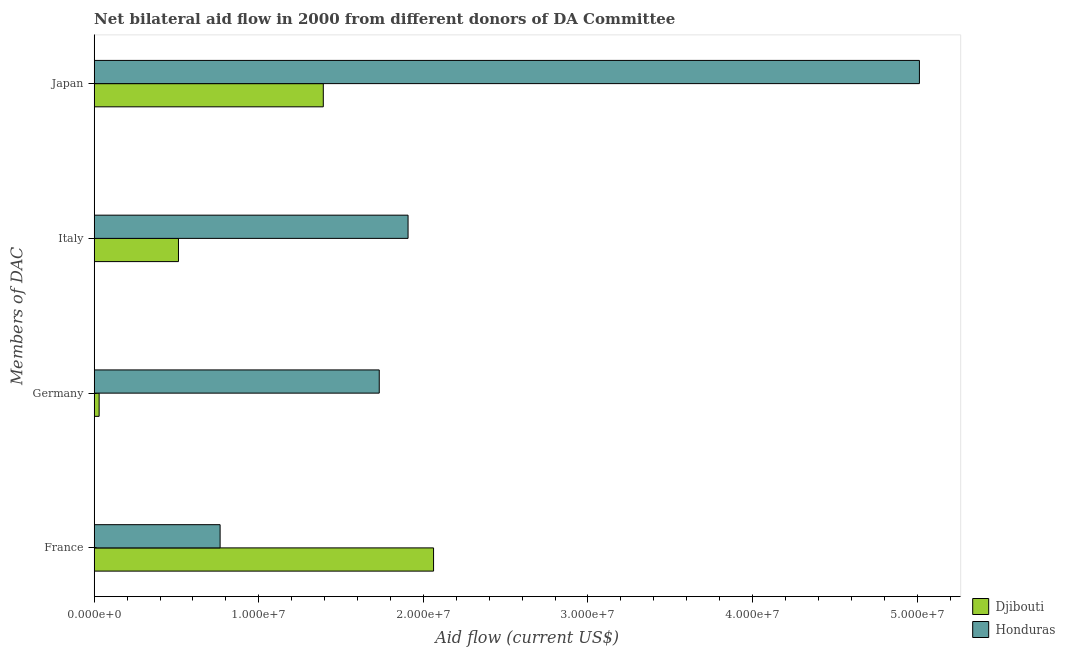How many different coloured bars are there?
Ensure brevity in your answer.  2. Are the number of bars on each tick of the Y-axis equal?
Provide a succinct answer. Yes. How many bars are there on the 2nd tick from the top?
Provide a short and direct response. 2. How many bars are there on the 3rd tick from the bottom?
Keep it short and to the point. 2. What is the label of the 3rd group of bars from the top?
Your answer should be very brief. Germany. What is the amount of aid given by france in Honduras?
Ensure brevity in your answer.  7.65e+06. Across all countries, what is the maximum amount of aid given by italy?
Make the answer very short. 1.91e+07. Across all countries, what is the minimum amount of aid given by france?
Provide a succinct answer. 7.65e+06. In which country was the amount of aid given by france maximum?
Make the answer very short. Djibouti. In which country was the amount of aid given by japan minimum?
Your response must be concise. Djibouti. What is the total amount of aid given by france in the graph?
Provide a succinct answer. 2.83e+07. What is the difference between the amount of aid given by italy in Djibouti and that in Honduras?
Provide a succinct answer. -1.40e+07. What is the difference between the amount of aid given by germany in Honduras and the amount of aid given by italy in Djibouti?
Your answer should be very brief. 1.22e+07. What is the average amount of aid given by germany per country?
Give a very brief answer. 8.81e+06. What is the difference between the amount of aid given by italy and amount of aid given by france in Djibouti?
Provide a succinct answer. -1.55e+07. What is the ratio of the amount of aid given by france in Honduras to that in Djibouti?
Offer a very short reply. 0.37. Is the difference between the amount of aid given by france in Honduras and Djibouti greater than the difference between the amount of aid given by germany in Honduras and Djibouti?
Give a very brief answer. No. What is the difference between the highest and the second highest amount of aid given by japan?
Offer a terse response. 3.62e+07. What is the difference between the highest and the lowest amount of aid given by italy?
Ensure brevity in your answer.  1.40e+07. Is the sum of the amount of aid given by japan in Honduras and Djibouti greater than the maximum amount of aid given by italy across all countries?
Your response must be concise. Yes. What does the 2nd bar from the top in Japan represents?
Provide a short and direct response. Djibouti. What does the 2nd bar from the bottom in France represents?
Your answer should be compact. Honduras. How many bars are there?
Your response must be concise. 8. Are all the bars in the graph horizontal?
Provide a short and direct response. Yes. Does the graph contain any zero values?
Keep it short and to the point. No. Does the graph contain grids?
Keep it short and to the point. No. How many legend labels are there?
Offer a very short reply. 2. How are the legend labels stacked?
Provide a short and direct response. Vertical. What is the title of the graph?
Offer a terse response. Net bilateral aid flow in 2000 from different donors of DA Committee. What is the label or title of the X-axis?
Your answer should be compact. Aid flow (current US$). What is the label or title of the Y-axis?
Give a very brief answer. Members of DAC. What is the Aid flow (current US$) of Djibouti in France?
Offer a terse response. 2.06e+07. What is the Aid flow (current US$) in Honduras in France?
Your answer should be very brief. 7.65e+06. What is the Aid flow (current US$) in Honduras in Germany?
Ensure brevity in your answer.  1.73e+07. What is the Aid flow (current US$) in Djibouti in Italy?
Ensure brevity in your answer.  5.12e+06. What is the Aid flow (current US$) in Honduras in Italy?
Ensure brevity in your answer.  1.91e+07. What is the Aid flow (current US$) in Djibouti in Japan?
Make the answer very short. 1.39e+07. What is the Aid flow (current US$) in Honduras in Japan?
Your response must be concise. 5.01e+07. Across all Members of DAC, what is the maximum Aid flow (current US$) of Djibouti?
Offer a very short reply. 2.06e+07. Across all Members of DAC, what is the maximum Aid flow (current US$) of Honduras?
Provide a succinct answer. 5.01e+07. Across all Members of DAC, what is the minimum Aid flow (current US$) in Djibouti?
Make the answer very short. 3.00e+05. Across all Members of DAC, what is the minimum Aid flow (current US$) of Honduras?
Keep it short and to the point. 7.65e+06. What is the total Aid flow (current US$) of Djibouti in the graph?
Your response must be concise. 4.00e+07. What is the total Aid flow (current US$) of Honduras in the graph?
Your response must be concise. 9.42e+07. What is the difference between the Aid flow (current US$) in Djibouti in France and that in Germany?
Offer a terse response. 2.03e+07. What is the difference between the Aid flow (current US$) in Honduras in France and that in Germany?
Your answer should be very brief. -9.67e+06. What is the difference between the Aid flow (current US$) in Djibouti in France and that in Italy?
Offer a very short reply. 1.55e+07. What is the difference between the Aid flow (current US$) of Honduras in France and that in Italy?
Your answer should be compact. -1.14e+07. What is the difference between the Aid flow (current US$) of Djibouti in France and that in Japan?
Make the answer very short. 6.70e+06. What is the difference between the Aid flow (current US$) of Honduras in France and that in Japan?
Offer a terse response. -4.25e+07. What is the difference between the Aid flow (current US$) of Djibouti in Germany and that in Italy?
Provide a succinct answer. -4.82e+06. What is the difference between the Aid flow (current US$) of Honduras in Germany and that in Italy?
Provide a succinct answer. -1.75e+06. What is the difference between the Aid flow (current US$) of Djibouti in Germany and that in Japan?
Provide a short and direct response. -1.36e+07. What is the difference between the Aid flow (current US$) of Honduras in Germany and that in Japan?
Make the answer very short. -3.28e+07. What is the difference between the Aid flow (current US$) in Djibouti in Italy and that in Japan?
Offer a terse response. -8.80e+06. What is the difference between the Aid flow (current US$) in Honduras in Italy and that in Japan?
Ensure brevity in your answer.  -3.11e+07. What is the difference between the Aid flow (current US$) in Djibouti in France and the Aid flow (current US$) in Honduras in Germany?
Your answer should be very brief. 3.30e+06. What is the difference between the Aid flow (current US$) in Djibouti in France and the Aid flow (current US$) in Honduras in Italy?
Your answer should be very brief. 1.55e+06. What is the difference between the Aid flow (current US$) of Djibouti in France and the Aid flow (current US$) of Honduras in Japan?
Give a very brief answer. -2.95e+07. What is the difference between the Aid flow (current US$) of Djibouti in Germany and the Aid flow (current US$) of Honduras in Italy?
Give a very brief answer. -1.88e+07. What is the difference between the Aid flow (current US$) in Djibouti in Germany and the Aid flow (current US$) in Honduras in Japan?
Your answer should be compact. -4.98e+07. What is the difference between the Aid flow (current US$) of Djibouti in Italy and the Aid flow (current US$) of Honduras in Japan?
Make the answer very short. -4.50e+07. What is the average Aid flow (current US$) of Djibouti per Members of DAC?
Make the answer very short. 9.99e+06. What is the average Aid flow (current US$) of Honduras per Members of DAC?
Provide a succinct answer. 2.35e+07. What is the difference between the Aid flow (current US$) in Djibouti and Aid flow (current US$) in Honduras in France?
Give a very brief answer. 1.30e+07. What is the difference between the Aid flow (current US$) in Djibouti and Aid flow (current US$) in Honduras in Germany?
Offer a very short reply. -1.70e+07. What is the difference between the Aid flow (current US$) of Djibouti and Aid flow (current US$) of Honduras in Italy?
Your answer should be compact. -1.40e+07. What is the difference between the Aid flow (current US$) in Djibouti and Aid flow (current US$) in Honduras in Japan?
Your response must be concise. -3.62e+07. What is the ratio of the Aid flow (current US$) of Djibouti in France to that in Germany?
Give a very brief answer. 68.73. What is the ratio of the Aid flow (current US$) in Honduras in France to that in Germany?
Ensure brevity in your answer.  0.44. What is the ratio of the Aid flow (current US$) in Djibouti in France to that in Italy?
Provide a short and direct response. 4.03. What is the ratio of the Aid flow (current US$) of Honduras in France to that in Italy?
Your answer should be compact. 0.4. What is the ratio of the Aid flow (current US$) in Djibouti in France to that in Japan?
Give a very brief answer. 1.48. What is the ratio of the Aid flow (current US$) of Honduras in France to that in Japan?
Your answer should be compact. 0.15. What is the ratio of the Aid flow (current US$) in Djibouti in Germany to that in Italy?
Your response must be concise. 0.06. What is the ratio of the Aid flow (current US$) of Honduras in Germany to that in Italy?
Provide a short and direct response. 0.91. What is the ratio of the Aid flow (current US$) in Djibouti in Germany to that in Japan?
Make the answer very short. 0.02. What is the ratio of the Aid flow (current US$) of Honduras in Germany to that in Japan?
Your answer should be very brief. 0.35. What is the ratio of the Aid flow (current US$) of Djibouti in Italy to that in Japan?
Ensure brevity in your answer.  0.37. What is the ratio of the Aid flow (current US$) of Honduras in Italy to that in Japan?
Give a very brief answer. 0.38. What is the difference between the highest and the second highest Aid flow (current US$) in Djibouti?
Offer a terse response. 6.70e+06. What is the difference between the highest and the second highest Aid flow (current US$) in Honduras?
Keep it short and to the point. 3.11e+07. What is the difference between the highest and the lowest Aid flow (current US$) of Djibouti?
Provide a short and direct response. 2.03e+07. What is the difference between the highest and the lowest Aid flow (current US$) of Honduras?
Provide a short and direct response. 4.25e+07. 